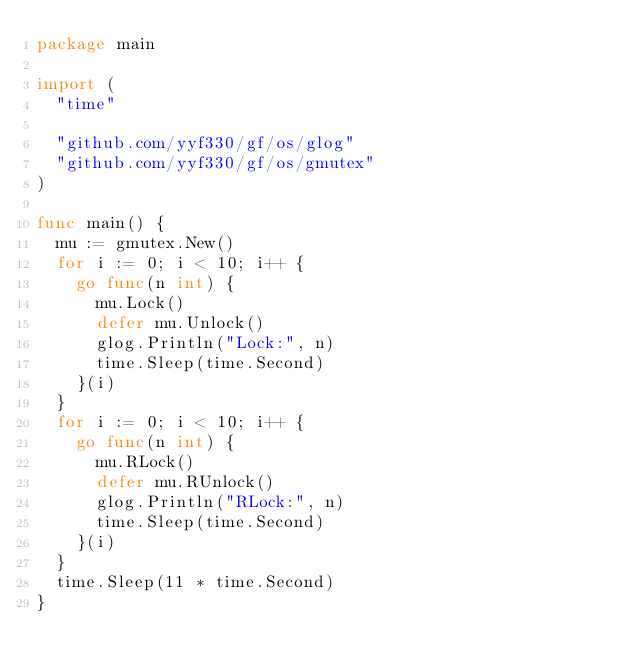Convert code to text. <code><loc_0><loc_0><loc_500><loc_500><_Go_>package main

import (
	"time"

	"github.com/yyf330/gf/os/glog"
	"github.com/yyf330/gf/os/gmutex"
)

func main() {
	mu := gmutex.New()
	for i := 0; i < 10; i++ {
		go func(n int) {
			mu.Lock()
			defer mu.Unlock()
			glog.Println("Lock:", n)
			time.Sleep(time.Second)
		}(i)
	}
	for i := 0; i < 10; i++ {
		go func(n int) {
			mu.RLock()
			defer mu.RUnlock()
			glog.Println("RLock:", n)
			time.Sleep(time.Second)
		}(i)
	}
	time.Sleep(11 * time.Second)
}
</code> 